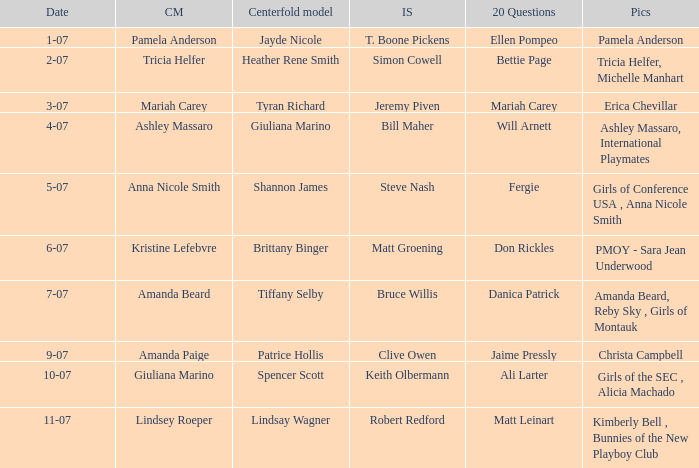Who was the centerfold model when the issue's pictorial was amanda beard, reby sky , girls of montauk ? Tiffany Selby. Can you parse all the data within this table? {'header': ['Date', 'CM', 'Centerfold model', 'IS', '20 Questions', 'Pics'], 'rows': [['1-07', 'Pamela Anderson', 'Jayde Nicole', 'T. Boone Pickens', 'Ellen Pompeo', 'Pamela Anderson'], ['2-07', 'Tricia Helfer', 'Heather Rene Smith', 'Simon Cowell', 'Bettie Page', 'Tricia Helfer, Michelle Manhart'], ['3-07', 'Mariah Carey', 'Tyran Richard', 'Jeremy Piven', 'Mariah Carey', 'Erica Chevillar'], ['4-07', 'Ashley Massaro', 'Giuliana Marino', 'Bill Maher', 'Will Arnett', 'Ashley Massaro, International Playmates'], ['5-07', 'Anna Nicole Smith', 'Shannon James', 'Steve Nash', 'Fergie', 'Girls of Conference USA , Anna Nicole Smith'], ['6-07', 'Kristine Lefebvre', 'Brittany Binger', 'Matt Groening', 'Don Rickles', 'PMOY - Sara Jean Underwood'], ['7-07', 'Amanda Beard', 'Tiffany Selby', 'Bruce Willis', 'Danica Patrick', 'Amanda Beard, Reby Sky , Girls of Montauk'], ['9-07', 'Amanda Paige', 'Patrice Hollis', 'Clive Owen', 'Jaime Pressly', 'Christa Campbell'], ['10-07', 'Giuliana Marino', 'Spencer Scott', 'Keith Olbermann', 'Ali Larter', 'Girls of the SEC , Alicia Machado'], ['11-07', 'Lindsey Roeper', 'Lindsay Wagner', 'Robert Redford', 'Matt Leinart', 'Kimberly Bell , Bunnies of the New Playboy Club']]} 